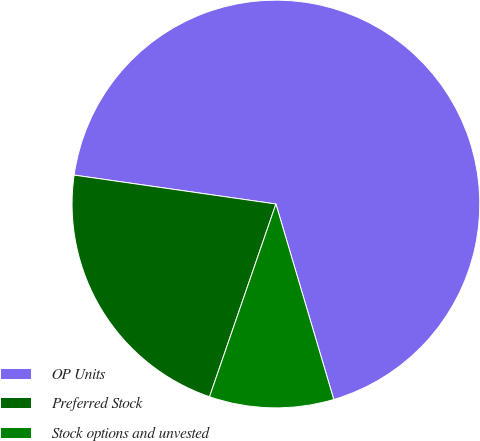Convert chart. <chart><loc_0><loc_0><loc_500><loc_500><pie_chart><fcel>OP Units<fcel>Preferred Stock<fcel>Stock options and unvested<nl><fcel>68.16%<fcel>21.99%<fcel>9.86%<nl></chart> 